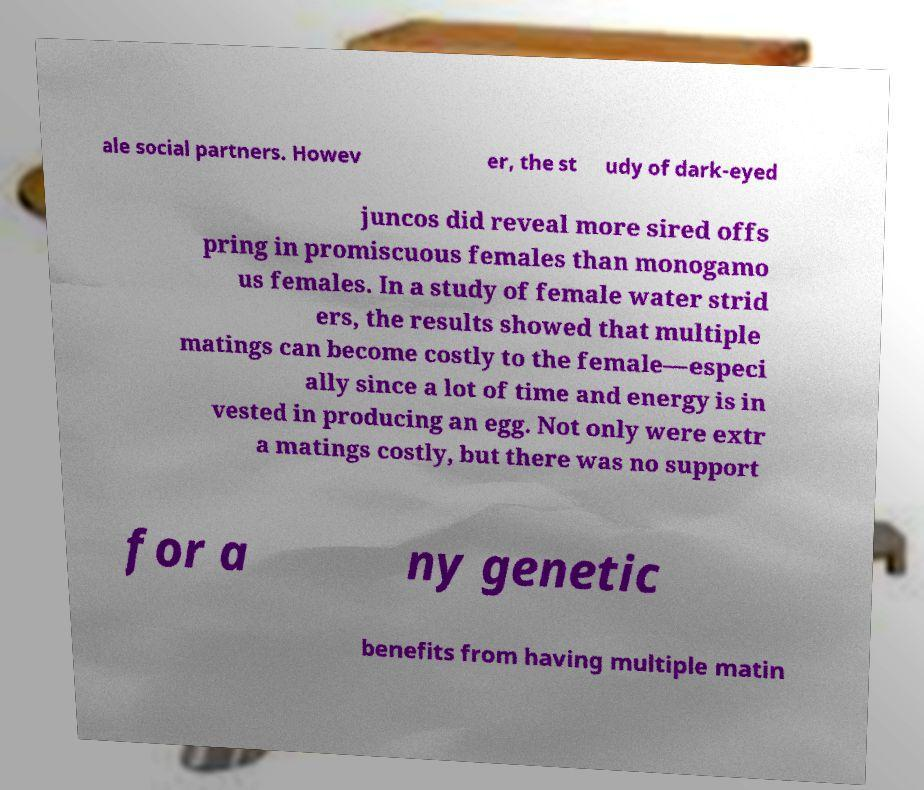Please identify and transcribe the text found in this image. ale social partners. Howev er, the st udy of dark-eyed juncos did reveal more sired offs pring in promiscuous females than monogamo us females. In a study of female water strid ers, the results showed that multiple matings can become costly to the female—especi ally since a lot of time and energy is in vested in producing an egg. Not only were extr a matings costly, but there was no support for a ny genetic benefits from having multiple matin 